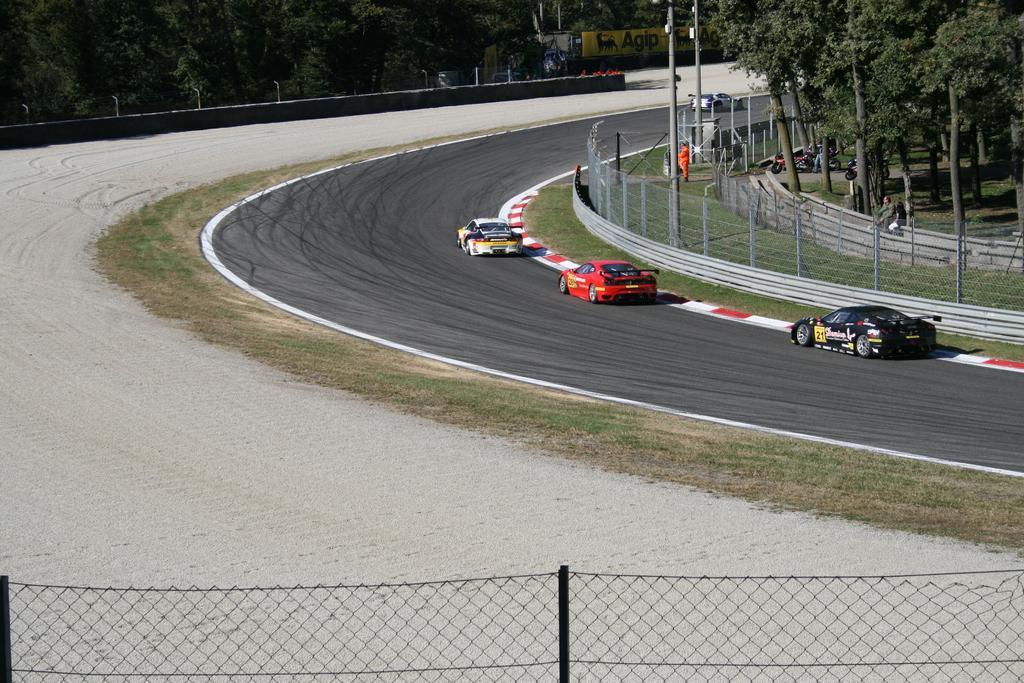Could you give a brief overview of what you see in this image? In this image there is a road. There are vehicles. There is grass. There are trees. There is a wall in the background. There is fencing in the foreground. 